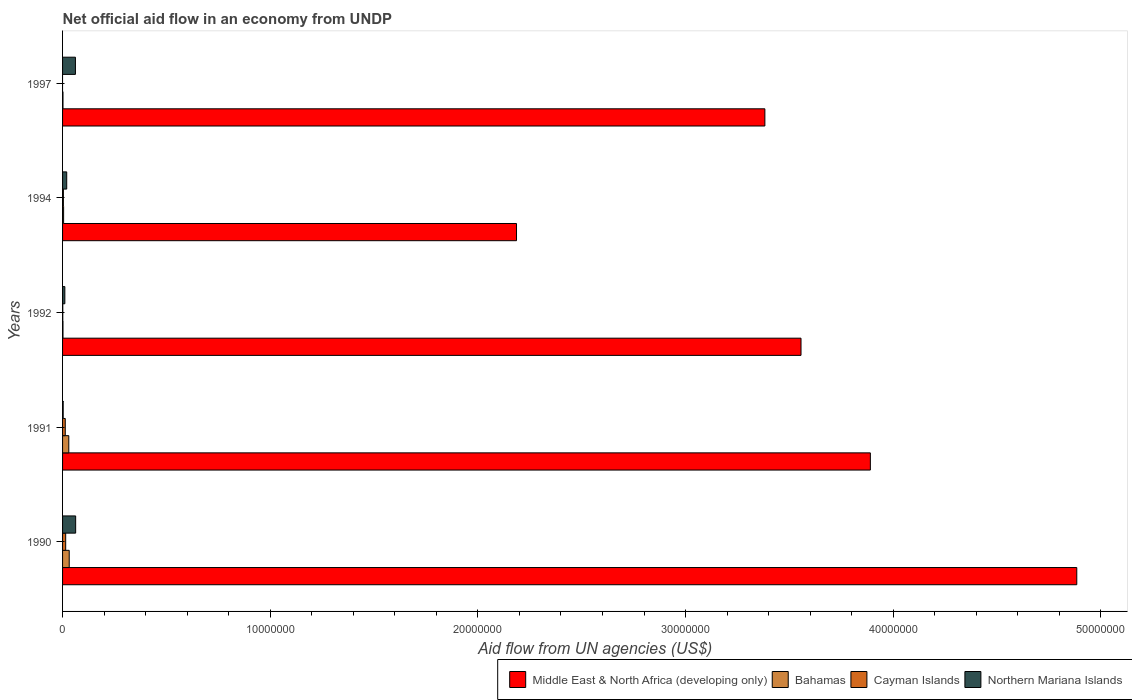How many different coloured bars are there?
Provide a short and direct response. 4. Are the number of bars per tick equal to the number of legend labels?
Make the answer very short. No. How many bars are there on the 1st tick from the top?
Provide a succinct answer. 3. What is the net official aid flow in Middle East & North Africa (developing only) in 1992?
Make the answer very short. 3.56e+07. Across all years, what is the maximum net official aid flow in Northern Mariana Islands?
Ensure brevity in your answer.  6.30e+05. Across all years, what is the minimum net official aid flow in Middle East & North Africa (developing only)?
Offer a very short reply. 2.19e+07. What is the total net official aid flow in Middle East & North Africa (developing only) in the graph?
Ensure brevity in your answer.  1.79e+08. What is the difference between the net official aid flow in Middle East & North Africa (developing only) in 1990 and that in 1997?
Make the answer very short. 1.50e+07. What is the difference between the net official aid flow in Bahamas in 1994 and the net official aid flow in Middle East & North Africa (developing only) in 1991?
Ensure brevity in your answer.  -3.88e+07. What is the average net official aid flow in Cayman Islands per year?
Provide a short and direct response. 6.60e+04. In the year 1994, what is the difference between the net official aid flow in Northern Mariana Islands and net official aid flow in Middle East & North Africa (developing only)?
Provide a short and direct response. -2.17e+07. What is the ratio of the net official aid flow in Bahamas in 1991 to that in 1992?
Your answer should be very brief. 15. Is the net official aid flow in Middle East & North Africa (developing only) in 1994 less than that in 1997?
Offer a terse response. Yes. Is the difference between the net official aid flow in Northern Mariana Islands in 1992 and 1997 greater than the difference between the net official aid flow in Middle East & North Africa (developing only) in 1992 and 1997?
Give a very brief answer. No. What is the difference between the highest and the lowest net official aid flow in Middle East & North Africa (developing only)?
Give a very brief answer. 2.70e+07. In how many years, is the net official aid flow in Cayman Islands greater than the average net official aid flow in Cayman Islands taken over all years?
Offer a terse response. 2. Is the sum of the net official aid flow in Middle East & North Africa (developing only) in 1991 and 1997 greater than the maximum net official aid flow in Bahamas across all years?
Offer a terse response. Yes. How many years are there in the graph?
Provide a succinct answer. 5. What is the difference between two consecutive major ticks on the X-axis?
Offer a very short reply. 1.00e+07. Does the graph contain any zero values?
Your answer should be very brief. Yes. Does the graph contain grids?
Keep it short and to the point. No. Where does the legend appear in the graph?
Your answer should be very brief. Bottom right. What is the title of the graph?
Your answer should be very brief. Net official aid flow in an economy from UNDP. What is the label or title of the X-axis?
Offer a very short reply. Aid flow from UN agencies (US$). What is the Aid flow from UN agencies (US$) of Middle East & North Africa (developing only) in 1990?
Provide a short and direct response. 4.88e+07. What is the Aid flow from UN agencies (US$) in Northern Mariana Islands in 1990?
Provide a short and direct response. 6.30e+05. What is the Aid flow from UN agencies (US$) of Middle East & North Africa (developing only) in 1991?
Keep it short and to the point. 3.89e+07. What is the Aid flow from UN agencies (US$) in Northern Mariana Islands in 1991?
Offer a terse response. 3.00e+04. What is the Aid flow from UN agencies (US$) in Middle East & North Africa (developing only) in 1992?
Make the answer very short. 3.56e+07. What is the Aid flow from UN agencies (US$) in Bahamas in 1992?
Provide a succinct answer. 2.00e+04. What is the Aid flow from UN agencies (US$) of Cayman Islands in 1992?
Provide a succinct answer. 10000. What is the Aid flow from UN agencies (US$) of Northern Mariana Islands in 1992?
Keep it short and to the point. 1.10e+05. What is the Aid flow from UN agencies (US$) of Middle East & North Africa (developing only) in 1994?
Offer a very short reply. 2.19e+07. What is the Aid flow from UN agencies (US$) in Middle East & North Africa (developing only) in 1997?
Your answer should be compact. 3.38e+07. What is the Aid flow from UN agencies (US$) in Northern Mariana Islands in 1997?
Make the answer very short. 6.20e+05. Across all years, what is the maximum Aid flow from UN agencies (US$) of Middle East & North Africa (developing only)?
Give a very brief answer. 4.88e+07. Across all years, what is the maximum Aid flow from UN agencies (US$) in Cayman Islands?
Keep it short and to the point. 1.50e+05. Across all years, what is the maximum Aid flow from UN agencies (US$) in Northern Mariana Islands?
Your answer should be compact. 6.30e+05. Across all years, what is the minimum Aid flow from UN agencies (US$) in Middle East & North Africa (developing only)?
Your response must be concise. 2.19e+07. What is the total Aid flow from UN agencies (US$) of Middle East & North Africa (developing only) in the graph?
Provide a succinct answer. 1.79e+08. What is the total Aid flow from UN agencies (US$) in Bahamas in the graph?
Make the answer very short. 7.10e+05. What is the total Aid flow from UN agencies (US$) in Cayman Islands in the graph?
Provide a short and direct response. 3.30e+05. What is the total Aid flow from UN agencies (US$) of Northern Mariana Islands in the graph?
Your answer should be compact. 1.59e+06. What is the difference between the Aid flow from UN agencies (US$) in Middle East & North Africa (developing only) in 1990 and that in 1991?
Your answer should be compact. 9.94e+06. What is the difference between the Aid flow from UN agencies (US$) of Bahamas in 1990 and that in 1991?
Provide a succinct answer. 2.00e+04. What is the difference between the Aid flow from UN agencies (US$) of Middle East & North Africa (developing only) in 1990 and that in 1992?
Offer a very short reply. 1.33e+07. What is the difference between the Aid flow from UN agencies (US$) of Bahamas in 1990 and that in 1992?
Provide a succinct answer. 3.00e+05. What is the difference between the Aid flow from UN agencies (US$) of Northern Mariana Islands in 1990 and that in 1992?
Your answer should be very brief. 5.20e+05. What is the difference between the Aid flow from UN agencies (US$) of Middle East & North Africa (developing only) in 1990 and that in 1994?
Make the answer very short. 2.70e+07. What is the difference between the Aid flow from UN agencies (US$) of Bahamas in 1990 and that in 1994?
Give a very brief answer. 2.70e+05. What is the difference between the Aid flow from UN agencies (US$) of Cayman Islands in 1990 and that in 1994?
Keep it short and to the point. 1.10e+05. What is the difference between the Aid flow from UN agencies (US$) of Northern Mariana Islands in 1990 and that in 1994?
Provide a succinct answer. 4.30e+05. What is the difference between the Aid flow from UN agencies (US$) of Middle East & North Africa (developing only) in 1990 and that in 1997?
Offer a very short reply. 1.50e+07. What is the difference between the Aid flow from UN agencies (US$) in Northern Mariana Islands in 1990 and that in 1997?
Your answer should be compact. 10000. What is the difference between the Aid flow from UN agencies (US$) in Middle East & North Africa (developing only) in 1991 and that in 1992?
Provide a succinct answer. 3.34e+06. What is the difference between the Aid flow from UN agencies (US$) in Bahamas in 1991 and that in 1992?
Keep it short and to the point. 2.80e+05. What is the difference between the Aid flow from UN agencies (US$) in Northern Mariana Islands in 1991 and that in 1992?
Offer a very short reply. -8.00e+04. What is the difference between the Aid flow from UN agencies (US$) in Middle East & North Africa (developing only) in 1991 and that in 1994?
Your answer should be very brief. 1.70e+07. What is the difference between the Aid flow from UN agencies (US$) of Cayman Islands in 1991 and that in 1994?
Ensure brevity in your answer.  9.00e+04. What is the difference between the Aid flow from UN agencies (US$) of Northern Mariana Islands in 1991 and that in 1994?
Give a very brief answer. -1.70e+05. What is the difference between the Aid flow from UN agencies (US$) of Middle East & North Africa (developing only) in 1991 and that in 1997?
Make the answer very short. 5.08e+06. What is the difference between the Aid flow from UN agencies (US$) of Northern Mariana Islands in 1991 and that in 1997?
Provide a short and direct response. -5.90e+05. What is the difference between the Aid flow from UN agencies (US$) in Middle East & North Africa (developing only) in 1992 and that in 1994?
Ensure brevity in your answer.  1.37e+07. What is the difference between the Aid flow from UN agencies (US$) of Bahamas in 1992 and that in 1994?
Your response must be concise. -3.00e+04. What is the difference between the Aid flow from UN agencies (US$) in Middle East & North Africa (developing only) in 1992 and that in 1997?
Offer a terse response. 1.74e+06. What is the difference between the Aid flow from UN agencies (US$) in Northern Mariana Islands in 1992 and that in 1997?
Your answer should be very brief. -5.10e+05. What is the difference between the Aid flow from UN agencies (US$) of Middle East & North Africa (developing only) in 1994 and that in 1997?
Your answer should be very brief. -1.20e+07. What is the difference between the Aid flow from UN agencies (US$) in Northern Mariana Islands in 1994 and that in 1997?
Ensure brevity in your answer.  -4.20e+05. What is the difference between the Aid flow from UN agencies (US$) in Middle East & North Africa (developing only) in 1990 and the Aid flow from UN agencies (US$) in Bahamas in 1991?
Give a very brief answer. 4.85e+07. What is the difference between the Aid flow from UN agencies (US$) of Middle East & North Africa (developing only) in 1990 and the Aid flow from UN agencies (US$) of Cayman Islands in 1991?
Your response must be concise. 4.87e+07. What is the difference between the Aid flow from UN agencies (US$) in Middle East & North Africa (developing only) in 1990 and the Aid flow from UN agencies (US$) in Northern Mariana Islands in 1991?
Provide a short and direct response. 4.88e+07. What is the difference between the Aid flow from UN agencies (US$) in Cayman Islands in 1990 and the Aid flow from UN agencies (US$) in Northern Mariana Islands in 1991?
Offer a terse response. 1.20e+05. What is the difference between the Aid flow from UN agencies (US$) of Middle East & North Africa (developing only) in 1990 and the Aid flow from UN agencies (US$) of Bahamas in 1992?
Your answer should be very brief. 4.88e+07. What is the difference between the Aid flow from UN agencies (US$) in Middle East & North Africa (developing only) in 1990 and the Aid flow from UN agencies (US$) in Cayman Islands in 1992?
Provide a short and direct response. 4.88e+07. What is the difference between the Aid flow from UN agencies (US$) of Middle East & North Africa (developing only) in 1990 and the Aid flow from UN agencies (US$) of Northern Mariana Islands in 1992?
Your answer should be compact. 4.87e+07. What is the difference between the Aid flow from UN agencies (US$) of Middle East & North Africa (developing only) in 1990 and the Aid flow from UN agencies (US$) of Bahamas in 1994?
Your answer should be very brief. 4.88e+07. What is the difference between the Aid flow from UN agencies (US$) of Middle East & North Africa (developing only) in 1990 and the Aid flow from UN agencies (US$) of Cayman Islands in 1994?
Provide a short and direct response. 4.88e+07. What is the difference between the Aid flow from UN agencies (US$) of Middle East & North Africa (developing only) in 1990 and the Aid flow from UN agencies (US$) of Northern Mariana Islands in 1994?
Give a very brief answer. 4.86e+07. What is the difference between the Aid flow from UN agencies (US$) in Bahamas in 1990 and the Aid flow from UN agencies (US$) in Cayman Islands in 1994?
Give a very brief answer. 2.80e+05. What is the difference between the Aid flow from UN agencies (US$) in Middle East & North Africa (developing only) in 1990 and the Aid flow from UN agencies (US$) in Bahamas in 1997?
Give a very brief answer. 4.88e+07. What is the difference between the Aid flow from UN agencies (US$) of Middle East & North Africa (developing only) in 1990 and the Aid flow from UN agencies (US$) of Northern Mariana Islands in 1997?
Your answer should be very brief. 4.82e+07. What is the difference between the Aid flow from UN agencies (US$) of Cayman Islands in 1990 and the Aid flow from UN agencies (US$) of Northern Mariana Islands in 1997?
Ensure brevity in your answer.  -4.70e+05. What is the difference between the Aid flow from UN agencies (US$) in Middle East & North Africa (developing only) in 1991 and the Aid flow from UN agencies (US$) in Bahamas in 1992?
Provide a short and direct response. 3.89e+07. What is the difference between the Aid flow from UN agencies (US$) in Middle East & North Africa (developing only) in 1991 and the Aid flow from UN agencies (US$) in Cayman Islands in 1992?
Provide a short and direct response. 3.89e+07. What is the difference between the Aid flow from UN agencies (US$) of Middle East & North Africa (developing only) in 1991 and the Aid flow from UN agencies (US$) of Northern Mariana Islands in 1992?
Make the answer very short. 3.88e+07. What is the difference between the Aid flow from UN agencies (US$) of Bahamas in 1991 and the Aid flow from UN agencies (US$) of Cayman Islands in 1992?
Your answer should be very brief. 2.90e+05. What is the difference between the Aid flow from UN agencies (US$) of Cayman Islands in 1991 and the Aid flow from UN agencies (US$) of Northern Mariana Islands in 1992?
Ensure brevity in your answer.  2.00e+04. What is the difference between the Aid flow from UN agencies (US$) of Middle East & North Africa (developing only) in 1991 and the Aid flow from UN agencies (US$) of Bahamas in 1994?
Ensure brevity in your answer.  3.88e+07. What is the difference between the Aid flow from UN agencies (US$) of Middle East & North Africa (developing only) in 1991 and the Aid flow from UN agencies (US$) of Cayman Islands in 1994?
Make the answer very short. 3.89e+07. What is the difference between the Aid flow from UN agencies (US$) of Middle East & North Africa (developing only) in 1991 and the Aid flow from UN agencies (US$) of Northern Mariana Islands in 1994?
Ensure brevity in your answer.  3.87e+07. What is the difference between the Aid flow from UN agencies (US$) in Middle East & North Africa (developing only) in 1991 and the Aid flow from UN agencies (US$) in Bahamas in 1997?
Offer a very short reply. 3.89e+07. What is the difference between the Aid flow from UN agencies (US$) of Middle East & North Africa (developing only) in 1991 and the Aid flow from UN agencies (US$) of Northern Mariana Islands in 1997?
Provide a succinct answer. 3.83e+07. What is the difference between the Aid flow from UN agencies (US$) of Bahamas in 1991 and the Aid flow from UN agencies (US$) of Northern Mariana Islands in 1997?
Your answer should be compact. -3.20e+05. What is the difference between the Aid flow from UN agencies (US$) of Cayman Islands in 1991 and the Aid flow from UN agencies (US$) of Northern Mariana Islands in 1997?
Make the answer very short. -4.90e+05. What is the difference between the Aid flow from UN agencies (US$) in Middle East & North Africa (developing only) in 1992 and the Aid flow from UN agencies (US$) in Bahamas in 1994?
Offer a very short reply. 3.55e+07. What is the difference between the Aid flow from UN agencies (US$) in Middle East & North Africa (developing only) in 1992 and the Aid flow from UN agencies (US$) in Cayman Islands in 1994?
Provide a short and direct response. 3.55e+07. What is the difference between the Aid flow from UN agencies (US$) of Middle East & North Africa (developing only) in 1992 and the Aid flow from UN agencies (US$) of Northern Mariana Islands in 1994?
Keep it short and to the point. 3.54e+07. What is the difference between the Aid flow from UN agencies (US$) of Bahamas in 1992 and the Aid flow from UN agencies (US$) of Cayman Islands in 1994?
Keep it short and to the point. -2.00e+04. What is the difference between the Aid flow from UN agencies (US$) of Bahamas in 1992 and the Aid flow from UN agencies (US$) of Northern Mariana Islands in 1994?
Offer a very short reply. -1.80e+05. What is the difference between the Aid flow from UN agencies (US$) in Cayman Islands in 1992 and the Aid flow from UN agencies (US$) in Northern Mariana Islands in 1994?
Offer a terse response. -1.90e+05. What is the difference between the Aid flow from UN agencies (US$) in Middle East & North Africa (developing only) in 1992 and the Aid flow from UN agencies (US$) in Bahamas in 1997?
Make the answer very short. 3.55e+07. What is the difference between the Aid flow from UN agencies (US$) in Middle East & North Africa (developing only) in 1992 and the Aid flow from UN agencies (US$) in Northern Mariana Islands in 1997?
Make the answer very short. 3.49e+07. What is the difference between the Aid flow from UN agencies (US$) of Bahamas in 1992 and the Aid flow from UN agencies (US$) of Northern Mariana Islands in 1997?
Your answer should be compact. -6.00e+05. What is the difference between the Aid flow from UN agencies (US$) in Cayman Islands in 1992 and the Aid flow from UN agencies (US$) in Northern Mariana Islands in 1997?
Provide a succinct answer. -6.10e+05. What is the difference between the Aid flow from UN agencies (US$) of Middle East & North Africa (developing only) in 1994 and the Aid flow from UN agencies (US$) of Bahamas in 1997?
Your answer should be compact. 2.18e+07. What is the difference between the Aid flow from UN agencies (US$) of Middle East & North Africa (developing only) in 1994 and the Aid flow from UN agencies (US$) of Northern Mariana Islands in 1997?
Your answer should be compact. 2.12e+07. What is the difference between the Aid flow from UN agencies (US$) in Bahamas in 1994 and the Aid flow from UN agencies (US$) in Northern Mariana Islands in 1997?
Keep it short and to the point. -5.70e+05. What is the difference between the Aid flow from UN agencies (US$) in Cayman Islands in 1994 and the Aid flow from UN agencies (US$) in Northern Mariana Islands in 1997?
Your answer should be very brief. -5.80e+05. What is the average Aid flow from UN agencies (US$) in Middle East & North Africa (developing only) per year?
Offer a terse response. 3.58e+07. What is the average Aid flow from UN agencies (US$) of Bahamas per year?
Make the answer very short. 1.42e+05. What is the average Aid flow from UN agencies (US$) in Cayman Islands per year?
Give a very brief answer. 6.60e+04. What is the average Aid flow from UN agencies (US$) in Northern Mariana Islands per year?
Provide a succinct answer. 3.18e+05. In the year 1990, what is the difference between the Aid flow from UN agencies (US$) in Middle East & North Africa (developing only) and Aid flow from UN agencies (US$) in Bahamas?
Offer a very short reply. 4.85e+07. In the year 1990, what is the difference between the Aid flow from UN agencies (US$) of Middle East & North Africa (developing only) and Aid flow from UN agencies (US$) of Cayman Islands?
Your answer should be compact. 4.87e+07. In the year 1990, what is the difference between the Aid flow from UN agencies (US$) of Middle East & North Africa (developing only) and Aid flow from UN agencies (US$) of Northern Mariana Islands?
Give a very brief answer. 4.82e+07. In the year 1990, what is the difference between the Aid flow from UN agencies (US$) in Bahamas and Aid flow from UN agencies (US$) in Cayman Islands?
Offer a terse response. 1.70e+05. In the year 1990, what is the difference between the Aid flow from UN agencies (US$) in Bahamas and Aid flow from UN agencies (US$) in Northern Mariana Islands?
Offer a very short reply. -3.10e+05. In the year 1990, what is the difference between the Aid flow from UN agencies (US$) in Cayman Islands and Aid flow from UN agencies (US$) in Northern Mariana Islands?
Give a very brief answer. -4.80e+05. In the year 1991, what is the difference between the Aid flow from UN agencies (US$) in Middle East & North Africa (developing only) and Aid flow from UN agencies (US$) in Bahamas?
Provide a short and direct response. 3.86e+07. In the year 1991, what is the difference between the Aid flow from UN agencies (US$) in Middle East & North Africa (developing only) and Aid flow from UN agencies (US$) in Cayman Islands?
Your answer should be very brief. 3.88e+07. In the year 1991, what is the difference between the Aid flow from UN agencies (US$) in Middle East & North Africa (developing only) and Aid flow from UN agencies (US$) in Northern Mariana Islands?
Your answer should be very brief. 3.89e+07. In the year 1991, what is the difference between the Aid flow from UN agencies (US$) of Cayman Islands and Aid flow from UN agencies (US$) of Northern Mariana Islands?
Keep it short and to the point. 1.00e+05. In the year 1992, what is the difference between the Aid flow from UN agencies (US$) in Middle East & North Africa (developing only) and Aid flow from UN agencies (US$) in Bahamas?
Your response must be concise. 3.55e+07. In the year 1992, what is the difference between the Aid flow from UN agencies (US$) in Middle East & North Africa (developing only) and Aid flow from UN agencies (US$) in Cayman Islands?
Provide a succinct answer. 3.56e+07. In the year 1992, what is the difference between the Aid flow from UN agencies (US$) of Middle East & North Africa (developing only) and Aid flow from UN agencies (US$) of Northern Mariana Islands?
Your answer should be very brief. 3.54e+07. In the year 1992, what is the difference between the Aid flow from UN agencies (US$) in Bahamas and Aid flow from UN agencies (US$) in Cayman Islands?
Provide a succinct answer. 10000. In the year 1992, what is the difference between the Aid flow from UN agencies (US$) of Bahamas and Aid flow from UN agencies (US$) of Northern Mariana Islands?
Provide a succinct answer. -9.00e+04. In the year 1994, what is the difference between the Aid flow from UN agencies (US$) in Middle East & North Africa (developing only) and Aid flow from UN agencies (US$) in Bahamas?
Ensure brevity in your answer.  2.18e+07. In the year 1994, what is the difference between the Aid flow from UN agencies (US$) of Middle East & North Africa (developing only) and Aid flow from UN agencies (US$) of Cayman Islands?
Offer a very short reply. 2.18e+07. In the year 1994, what is the difference between the Aid flow from UN agencies (US$) of Middle East & North Africa (developing only) and Aid flow from UN agencies (US$) of Northern Mariana Islands?
Ensure brevity in your answer.  2.17e+07. In the year 1994, what is the difference between the Aid flow from UN agencies (US$) in Bahamas and Aid flow from UN agencies (US$) in Cayman Islands?
Keep it short and to the point. 10000. In the year 1994, what is the difference between the Aid flow from UN agencies (US$) of Cayman Islands and Aid flow from UN agencies (US$) of Northern Mariana Islands?
Your answer should be compact. -1.60e+05. In the year 1997, what is the difference between the Aid flow from UN agencies (US$) of Middle East & North Africa (developing only) and Aid flow from UN agencies (US$) of Bahamas?
Your answer should be compact. 3.38e+07. In the year 1997, what is the difference between the Aid flow from UN agencies (US$) in Middle East & North Africa (developing only) and Aid flow from UN agencies (US$) in Northern Mariana Islands?
Ensure brevity in your answer.  3.32e+07. In the year 1997, what is the difference between the Aid flow from UN agencies (US$) in Bahamas and Aid flow from UN agencies (US$) in Northern Mariana Islands?
Give a very brief answer. -6.00e+05. What is the ratio of the Aid flow from UN agencies (US$) of Middle East & North Africa (developing only) in 1990 to that in 1991?
Your answer should be very brief. 1.26. What is the ratio of the Aid flow from UN agencies (US$) in Bahamas in 1990 to that in 1991?
Your answer should be very brief. 1.07. What is the ratio of the Aid flow from UN agencies (US$) in Cayman Islands in 1990 to that in 1991?
Ensure brevity in your answer.  1.15. What is the ratio of the Aid flow from UN agencies (US$) of Northern Mariana Islands in 1990 to that in 1991?
Keep it short and to the point. 21. What is the ratio of the Aid flow from UN agencies (US$) in Middle East & North Africa (developing only) in 1990 to that in 1992?
Provide a short and direct response. 1.37. What is the ratio of the Aid flow from UN agencies (US$) of Bahamas in 1990 to that in 1992?
Give a very brief answer. 16. What is the ratio of the Aid flow from UN agencies (US$) of Northern Mariana Islands in 1990 to that in 1992?
Offer a terse response. 5.73. What is the ratio of the Aid flow from UN agencies (US$) in Middle East & North Africa (developing only) in 1990 to that in 1994?
Your response must be concise. 2.23. What is the ratio of the Aid flow from UN agencies (US$) of Cayman Islands in 1990 to that in 1994?
Provide a short and direct response. 3.75. What is the ratio of the Aid flow from UN agencies (US$) of Northern Mariana Islands in 1990 to that in 1994?
Your answer should be compact. 3.15. What is the ratio of the Aid flow from UN agencies (US$) in Middle East & North Africa (developing only) in 1990 to that in 1997?
Ensure brevity in your answer.  1.44. What is the ratio of the Aid flow from UN agencies (US$) in Northern Mariana Islands in 1990 to that in 1997?
Offer a terse response. 1.02. What is the ratio of the Aid flow from UN agencies (US$) in Middle East & North Africa (developing only) in 1991 to that in 1992?
Your answer should be compact. 1.09. What is the ratio of the Aid flow from UN agencies (US$) of Northern Mariana Islands in 1991 to that in 1992?
Make the answer very short. 0.27. What is the ratio of the Aid flow from UN agencies (US$) in Middle East & North Africa (developing only) in 1991 to that in 1994?
Your answer should be very brief. 1.78. What is the ratio of the Aid flow from UN agencies (US$) of Cayman Islands in 1991 to that in 1994?
Give a very brief answer. 3.25. What is the ratio of the Aid flow from UN agencies (US$) of Northern Mariana Islands in 1991 to that in 1994?
Your response must be concise. 0.15. What is the ratio of the Aid flow from UN agencies (US$) in Middle East & North Africa (developing only) in 1991 to that in 1997?
Your answer should be compact. 1.15. What is the ratio of the Aid flow from UN agencies (US$) in Northern Mariana Islands in 1991 to that in 1997?
Make the answer very short. 0.05. What is the ratio of the Aid flow from UN agencies (US$) of Middle East & North Africa (developing only) in 1992 to that in 1994?
Give a very brief answer. 1.63. What is the ratio of the Aid flow from UN agencies (US$) of Cayman Islands in 1992 to that in 1994?
Your response must be concise. 0.25. What is the ratio of the Aid flow from UN agencies (US$) in Northern Mariana Islands in 1992 to that in 1994?
Provide a short and direct response. 0.55. What is the ratio of the Aid flow from UN agencies (US$) of Middle East & North Africa (developing only) in 1992 to that in 1997?
Offer a very short reply. 1.05. What is the ratio of the Aid flow from UN agencies (US$) in Bahamas in 1992 to that in 1997?
Your answer should be compact. 1. What is the ratio of the Aid flow from UN agencies (US$) of Northern Mariana Islands in 1992 to that in 1997?
Offer a very short reply. 0.18. What is the ratio of the Aid flow from UN agencies (US$) in Middle East & North Africa (developing only) in 1994 to that in 1997?
Provide a short and direct response. 0.65. What is the ratio of the Aid flow from UN agencies (US$) in Bahamas in 1994 to that in 1997?
Ensure brevity in your answer.  2.5. What is the ratio of the Aid flow from UN agencies (US$) in Northern Mariana Islands in 1994 to that in 1997?
Your answer should be very brief. 0.32. What is the difference between the highest and the second highest Aid flow from UN agencies (US$) of Middle East & North Africa (developing only)?
Give a very brief answer. 9.94e+06. What is the difference between the highest and the second highest Aid flow from UN agencies (US$) in Cayman Islands?
Offer a terse response. 2.00e+04. What is the difference between the highest and the second highest Aid flow from UN agencies (US$) in Northern Mariana Islands?
Your answer should be compact. 10000. What is the difference between the highest and the lowest Aid flow from UN agencies (US$) in Middle East & North Africa (developing only)?
Offer a very short reply. 2.70e+07. What is the difference between the highest and the lowest Aid flow from UN agencies (US$) of Cayman Islands?
Make the answer very short. 1.50e+05. 